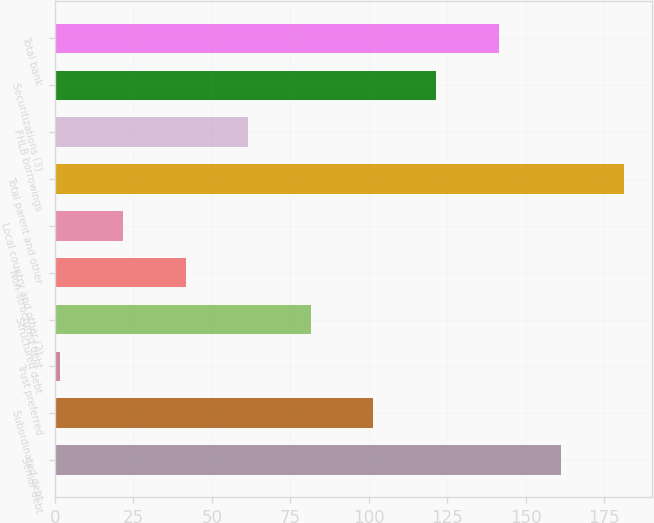<chart> <loc_0><loc_0><loc_500><loc_500><bar_chart><fcel>Senior debt<fcel>Subordinated debt<fcel>Trust preferred<fcel>Structured debt<fcel>Non-structured debt<fcel>Local country and other (2)<fcel>Total parent and other<fcel>FHLB borrowings<fcel>Securitizations (3)<fcel>Total bank<nl><fcel>161.38<fcel>101.5<fcel>1.7<fcel>81.54<fcel>41.62<fcel>21.66<fcel>181.34<fcel>61.58<fcel>121.46<fcel>141.42<nl></chart> 